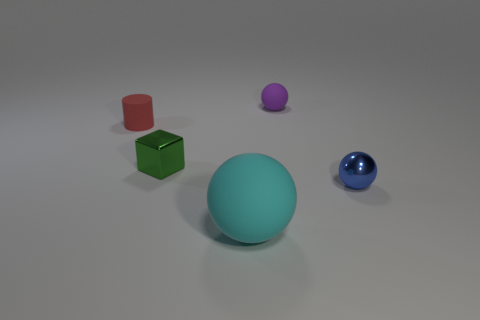Add 4 purple spheres. How many objects exist? 9 Subtract all blocks. How many objects are left? 4 Add 2 big cyan matte spheres. How many big cyan matte spheres are left? 3 Add 4 large cyan cylinders. How many large cyan cylinders exist? 4 Subtract 0 brown cubes. How many objects are left? 5 Subtract all big cyan metal cylinders. Subtract all tiny cylinders. How many objects are left? 4 